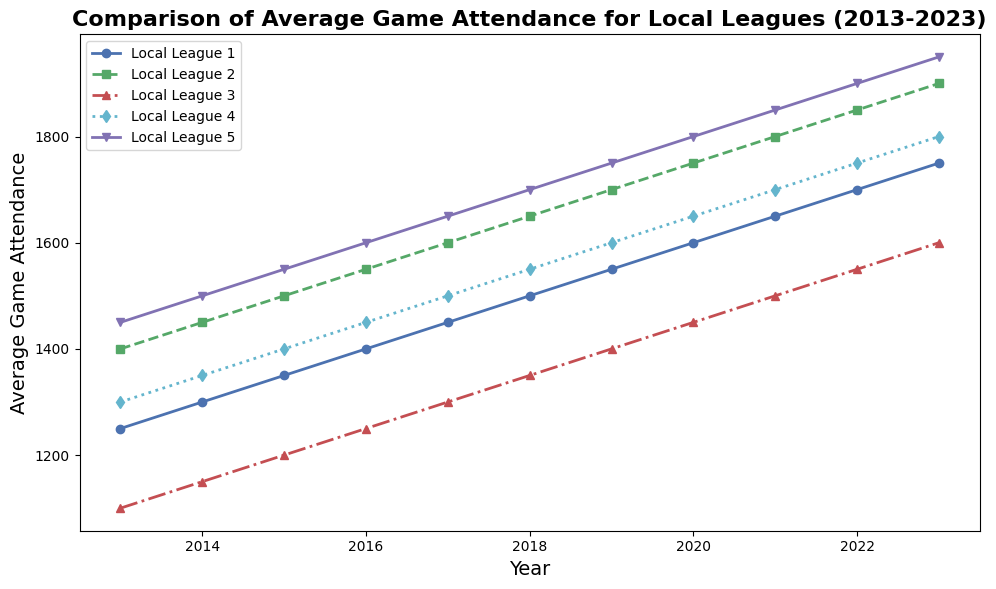Which league had the highest average game attendance in 2023? From the chart, look at the markers and lines corresponding to the year 2023. The line representing Local League 5 has the highest point in this year.
Answer: Local League 5 Between 2015 and 2020, which local league showed the most consistent increase in average game attendance? Observe the lines between the years 2015 and 2020 for each league. The line for Local League 1 shows a very steady and consistent increase during this period.
Answer: Local League 1 What is the difference in average game attendance between Local League 2 and Local League 3 in 2020? Find the data points for Local League 2 and Local League 3 in 2020. Local League 2 has an attendance of 1750, and Local League 3 has 1450. The difference is 1750 - 1450.
Answer: 300 Which league had the lowest average game attendance in 2015, and what was the attendance figure? Look at the lines corresponding to the year 2015 and identify the lowest point among all lines. Local League 3 had the lowest average attendance with 1200.
Answer: Local League 3, 1200 How many leagues had an average game attendance of at least 1500 in 2017? Count the number of lines that have a value of 1500 or greater in the year 2017. Local League 1, Local League 2, Local League 4, and Local League 5 exceed 1500.
Answer: 4 leagues Which local league had the most significant increase in average game attendance from 2013 to 2023? Compare the lines' slopes from 2013 to 2023. Local League 5 shows the steepest slope, indicating the most significant increase in attendance.
Answer: Local League 5 In which year did Local League 4 surpass an average game attendance of 1600? Track the line for Local League 4 and note the year where it first exceeds 1600. This happened in 2021.
Answer: 2021 If the average increase in game attendance per year for Local League 2 remains consistent, what would be the expected attendance in 2024? The attendance increases by 50 each year. In 2023, it reached 1900. Hence, in 2024, it would be 1900 + 50.
Answer: 1950 